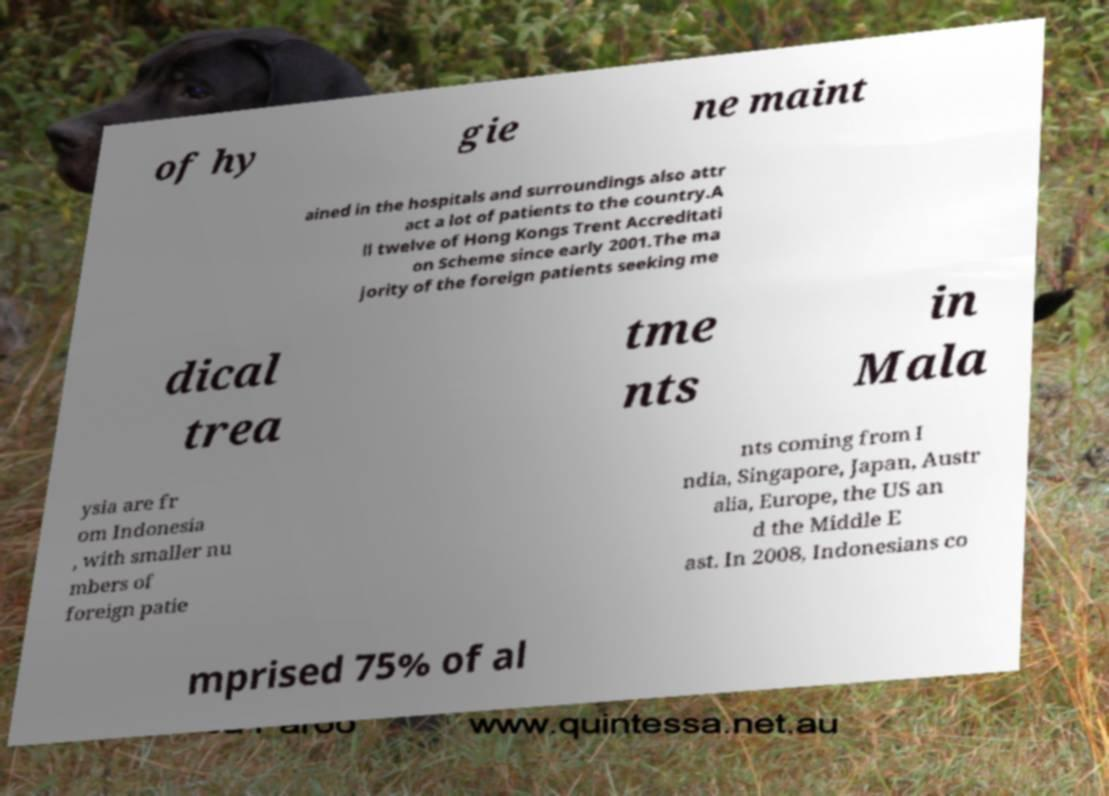Can you read and provide the text displayed in the image?This photo seems to have some interesting text. Can you extract and type it out for me? of hy gie ne maint ained in the hospitals and surroundings also attr act a lot of patients to the country.A ll twelve of Hong Kongs Trent Accreditati on Scheme since early 2001.The ma jority of the foreign patients seeking me dical trea tme nts in Mala ysia are fr om Indonesia , with smaller nu mbers of foreign patie nts coming from I ndia, Singapore, Japan, Austr alia, Europe, the US an d the Middle E ast. In 2008, Indonesians co mprised 75% of al 